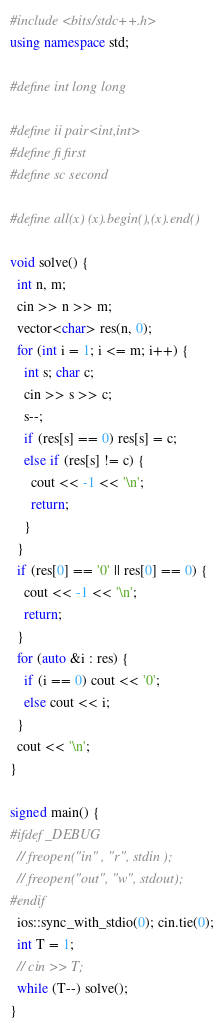Convert code to text. <code><loc_0><loc_0><loc_500><loc_500><_C++_>#include <bits/stdc++.h>
using namespace std;

#define int long long

#define ii pair<int,int>
#define fi first
#define sc second

#define all(x) (x).begin(),(x).end()

void solve() {
  int n, m;
  cin >> n >> m;
  vector<char> res(n, 0);
  for (int i = 1; i <= m; i++) {
    int s; char c;
    cin >> s >> c;
    s--;
    if (res[s] == 0) res[s] = c;
    else if (res[s] != c) {
      cout << -1 << '\n';
      return;
    }
  }
  if (res[0] == '0' || res[0] == 0) {
    cout << -1 << '\n';
    return;
  }
  for (auto &i : res) {
    if (i == 0) cout << '0';
    else cout << i;
  }
  cout << '\n';
}

signed main() {
#ifdef _DEBUG
  // freopen("in" , "r", stdin );
  // freopen("out", "w", stdout);
#endif
  ios::sync_with_stdio(0); cin.tie(0);
  int T = 1;
  // cin >> T;
  while (T--) solve();
}
</code> 